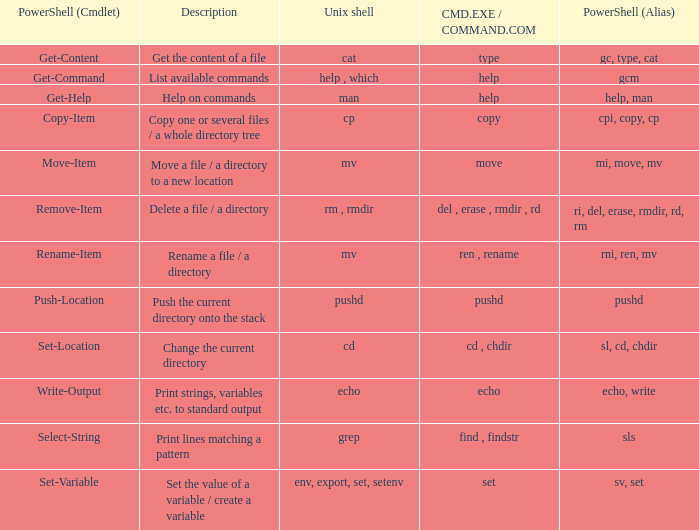When the cmd.exe / command.com is type, what are all associated values for powershell (cmdlet)? Get-Content. 